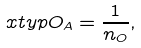<formula> <loc_0><loc_0><loc_500><loc_500>\ x t y p O _ { A } = \frac { 1 } { n _ { O } } ,</formula> 